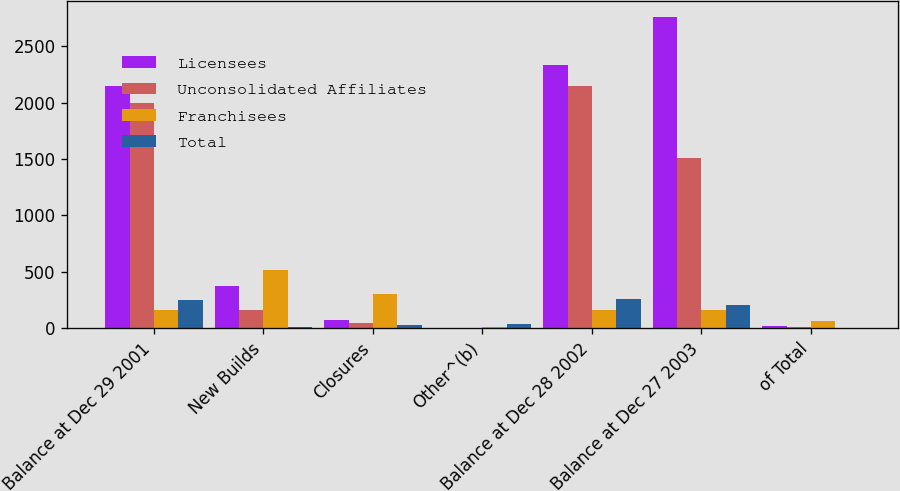Convert chart to OTSL. <chart><loc_0><loc_0><loc_500><loc_500><stacked_bar_chart><ecel><fcel>Balance at Dec 29 2001<fcel>New Builds<fcel>Closures<fcel>Other^(b)<fcel>Balance at Dec 28 2002<fcel>Balance at Dec 27 2003<fcel>of Total<nl><fcel>Licensees<fcel>2151<fcel>375<fcel>71<fcel>1<fcel>2333<fcel>2760<fcel>22<nl><fcel>Unconsolidated Affiliates<fcel>2000<fcel>161<fcel>46<fcel>2<fcel>2144<fcel>1506<fcel>12<nl><fcel>Franchisees<fcel>161<fcel>515<fcel>298<fcel>10<fcel>161<fcel>161<fcel>64<nl><fcel>Total<fcel>246<fcel>10<fcel>27<fcel>31<fcel>260<fcel>206<fcel>2<nl></chart> 